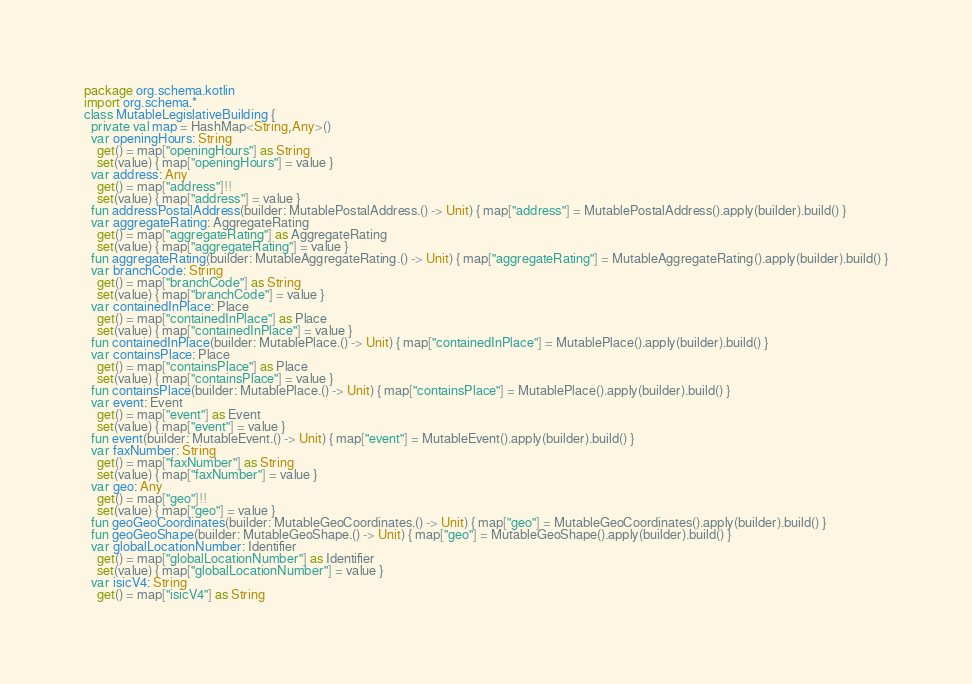<code> <loc_0><loc_0><loc_500><loc_500><_Kotlin_>package org.schema.kotlin
import org.schema.*
class MutableLegislativeBuilding {
  private val map = HashMap<String,Any>()
  var openingHours: String
    get() = map["openingHours"] as String
    set(value) { map["openingHours"] = value }
  var address: Any
    get() = map["address"]!!
    set(value) { map["address"] = value }
  fun addressPostalAddress(builder: MutablePostalAddress.() -> Unit) { map["address"] = MutablePostalAddress().apply(builder).build() }
  var aggregateRating: AggregateRating
    get() = map["aggregateRating"] as AggregateRating
    set(value) { map["aggregateRating"] = value }
  fun aggregateRating(builder: MutableAggregateRating.() -> Unit) { map["aggregateRating"] = MutableAggregateRating().apply(builder).build() }
  var branchCode: String
    get() = map["branchCode"] as String
    set(value) { map["branchCode"] = value }
  var containedInPlace: Place
    get() = map["containedInPlace"] as Place
    set(value) { map["containedInPlace"] = value }
  fun containedInPlace(builder: MutablePlace.() -> Unit) { map["containedInPlace"] = MutablePlace().apply(builder).build() }
  var containsPlace: Place
    get() = map["containsPlace"] as Place
    set(value) { map["containsPlace"] = value }
  fun containsPlace(builder: MutablePlace.() -> Unit) { map["containsPlace"] = MutablePlace().apply(builder).build() }
  var event: Event
    get() = map["event"] as Event
    set(value) { map["event"] = value }
  fun event(builder: MutableEvent.() -> Unit) { map["event"] = MutableEvent().apply(builder).build() }
  var faxNumber: String
    get() = map["faxNumber"] as String
    set(value) { map["faxNumber"] = value }
  var geo: Any
    get() = map["geo"]!!
    set(value) { map["geo"] = value }
  fun geoGeoCoordinates(builder: MutableGeoCoordinates.() -> Unit) { map["geo"] = MutableGeoCoordinates().apply(builder).build() }
  fun geoGeoShape(builder: MutableGeoShape.() -> Unit) { map["geo"] = MutableGeoShape().apply(builder).build() }
  var globalLocationNumber: Identifier
    get() = map["globalLocationNumber"] as Identifier
    set(value) { map["globalLocationNumber"] = value }
  var isicV4: String
    get() = map["isicV4"] as String</code> 